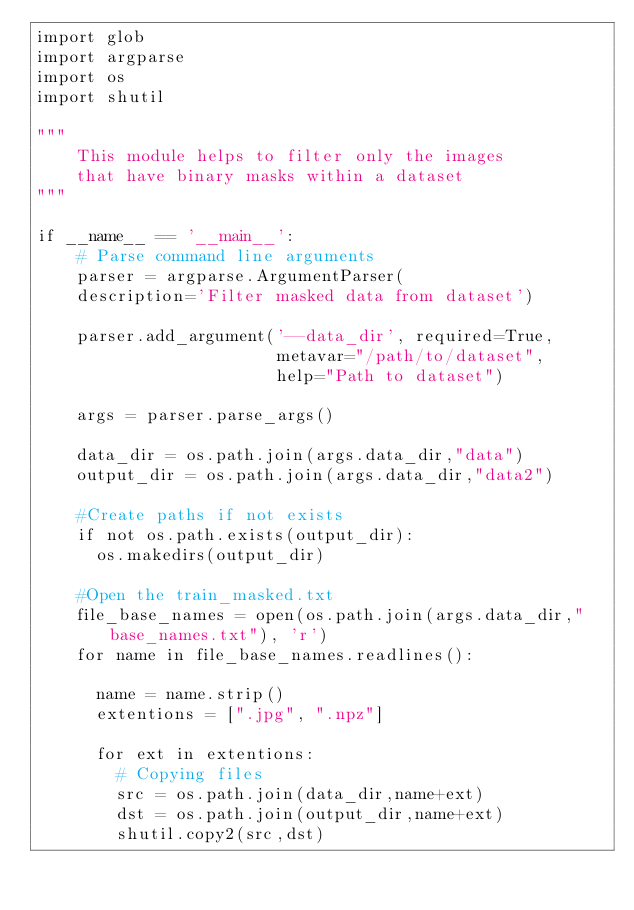<code> <loc_0><loc_0><loc_500><loc_500><_Python_>import glob
import argparse
import os
import shutil

"""
    This module helps to filter only the images 
    that have binary masks within a dataset 
"""

if __name__ == '__main__':
    # Parse command line arguments
    parser = argparse.ArgumentParser(
		description='Filter masked data from dataset')

    parser.add_argument('--data_dir', required=True,
                        metavar="/path/to/dataset",
                        help="Path to dataset")        

    args = parser.parse_args()
    
    data_dir = os.path.join(args.data_dir,"data")
    output_dir = os.path.join(args.data_dir,"data2")

    #Create paths if not exists
    if not os.path.exists(output_dir):
      os.makedirs(output_dir)

    #Open the train_masked.txt 
    file_base_names = open(os.path.join(args.data_dir,"base_names.txt"), 'r') 
    for name in file_base_names.readlines():
      
      name = name.strip()
      extentions = [".jpg", ".npz"]

      for ext in extentions:
        # Copying files
        src = os.path.join(data_dir,name+ext)
        dst = os.path.join(output_dir,name+ext)
        shutil.copy2(src,dst)</code> 